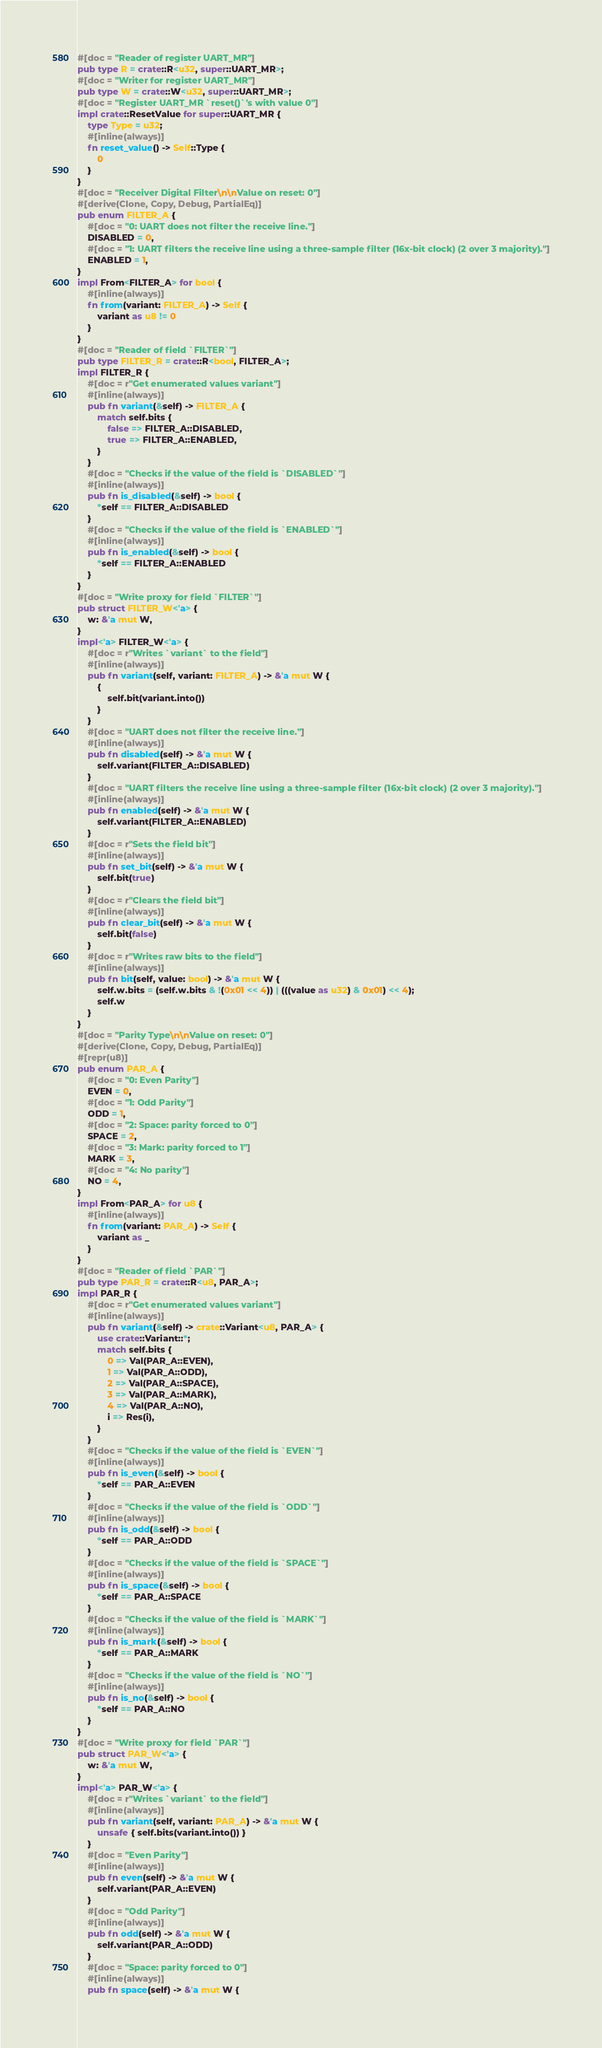<code> <loc_0><loc_0><loc_500><loc_500><_Rust_>#[doc = "Reader of register UART_MR"]
pub type R = crate::R<u32, super::UART_MR>;
#[doc = "Writer for register UART_MR"]
pub type W = crate::W<u32, super::UART_MR>;
#[doc = "Register UART_MR `reset()`'s with value 0"]
impl crate::ResetValue for super::UART_MR {
    type Type = u32;
    #[inline(always)]
    fn reset_value() -> Self::Type {
        0
    }
}
#[doc = "Receiver Digital Filter\n\nValue on reset: 0"]
#[derive(Clone, Copy, Debug, PartialEq)]
pub enum FILTER_A {
    #[doc = "0: UART does not filter the receive line."]
    DISABLED = 0,
    #[doc = "1: UART filters the receive line using a three-sample filter (16x-bit clock) (2 over 3 majority)."]
    ENABLED = 1,
}
impl From<FILTER_A> for bool {
    #[inline(always)]
    fn from(variant: FILTER_A) -> Self {
        variant as u8 != 0
    }
}
#[doc = "Reader of field `FILTER`"]
pub type FILTER_R = crate::R<bool, FILTER_A>;
impl FILTER_R {
    #[doc = r"Get enumerated values variant"]
    #[inline(always)]
    pub fn variant(&self) -> FILTER_A {
        match self.bits {
            false => FILTER_A::DISABLED,
            true => FILTER_A::ENABLED,
        }
    }
    #[doc = "Checks if the value of the field is `DISABLED`"]
    #[inline(always)]
    pub fn is_disabled(&self) -> bool {
        *self == FILTER_A::DISABLED
    }
    #[doc = "Checks if the value of the field is `ENABLED`"]
    #[inline(always)]
    pub fn is_enabled(&self) -> bool {
        *self == FILTER_A::ENABLED
    }
}
#[doc = "Write proxy for field `FILTER`"]
pub struct FILTER_W<'a> {
    w: &'a mut W,
}
impl<'a> FILTER_W<'a> {
    #[doc = r"Writes `variant` to the field"]
    #[inline(always)]
    pub fn variant(self, variant: FILTER_A) -> &'a mut W {
        {
            self.bit(variant.into())
        }
    }
    #[doc = "UART does not filter the receive line."]
    #[inline(always)]
    pub fn disabled(self) -> &'a mut W {
        self.variant(FILTER_A::DISABLED)
    }
    #[doc = "UART filters the receive line using a three-sample filter (16x-bit clock) (2 over 3 majority)."]
    #[inline(always)]
    pub fn enabled(self) -> &'a mut W {
        self.variant(FILTER_A::ENABLED)
    }
    #[doc = r"Sets the field bit"]
    #[inline(always)]
    pub fn set_bit(self) -> &'a mut W {
        self.bit(true)
    }
    #[doc = r"Clears the field bit"]
    #[inline(always)]
    pub fn clear_bit(self) -> &'a mut W {
        self.bit(false)
    }
    #[doc = r"Writes raw bits to the field"]
    #[inline(always)]
    pub fn bit(self, value: bool) -> &'a mut W {
        self.w.bits = (self.w.bits & !(0x01 << 4)) | (((value as u32) & 0x01) << 4);
        self.w
    }
}
#[doc = "Parity Type\n\nValue on reset: 0"]
#[derive(Clone, Copy, Debug, PartialEq)]
#[repr(u8)]
pub enum PAR_A {
    #[doc = "0: Even Parity"]
    EVEN = 0,
    #[doc = "1: Odd Parity"]
    ODD = 1,
    #[doc = "2: Space: parity forced to 0"]
    SPACE = 2,
    #[doc = "3: Mark: parity forced to 1"]
    MARK = 3,
    #[doc = "4: No parity"]
    NO = 4,
}
impl From<PAR_A> for u8 {
    #[inline(always)]
    fn from(variant: PAR_A) -> Self {
        variant as _
    }
}
#[doc = "Reader of field `PAR`"]
pub type PAR_R = crate::R<u8, PAR_A>;
impl PAR_R {
    #[doc = r"Get enumerated values variant"]
    #[inline(always)]
    pub fn variant(&self) -> crate::Variant<u8, PAR_A> {
        use crate::Variant::*;
        match self.bits {
            0 => Val(PAR_A::EVEN),
            1 => Val(PAR_A::ODD),
            2 => Val(PAR_A::SPACE),
            3 => Val(PAR_A::MARK),
            4 => Val(PAR_A::NO),
            i => Res(i),
        }
    }
    #[doc = "Checks if the value of the field is `EVEN`"]
    #[inline(always)]
    pub fn is_even(&self) -> bool {
        *self == PAR_A::EVEN
    }
    #[doc = "Checks if the value of the field is `ODD`"]
    #[inline(always)]
    pub fn is_odd(&self) -> bool {
        *self == PAR_A::ODD
    }
    #[doc = "Checks if the value of the field is `SPACE`"]
    #[inline(always)]
    pub fn is_space(&self) -> bool {
        *self == PAR_A::SPACE
    }
    #[doc = "Checks if the value of the field is `MARK`"]
    #[inline(always)]
    pub fn is_mark(&self) -> bool {
        *self == PAR_A::MARK
    }
    #[doc = "Checks if the value of the field is `NO`"]
    #[inline(always)]
    pub fn is_no(&self) -> bool {
        *self == PAR_A::NO
    }
}
#[doc = "Write proxy for field `PAR`"]
pub struct PAR_W<'a> {
    w: &'a mut W,
}
impl<'a> PAR_W<'a> {
    #[doc = r"Writes `variant` to the field"]
    #[inline(always)]
    pub fn variant(self, variant: PAR_A) -> &'a mut W {
        unsafe { self.bits(variant.into()) }
    }
    #[doc = "Even Parity"]
    #[inline(always)]
    pub fn even(self) -> &'a mut W {
        self.variant(PAR_A::EVEN)
    }
    #[doc = "Odd Parity"]
    #[inline(always)]
    pub fn odd(self) -> &'a mut W {
        self.variant(PAR_A::ODD)
    }
    #[doc = "Space: parity forced to 0"]
    #[inline(always)]
    pub fn space(self) -> &'a mut W {</code> 